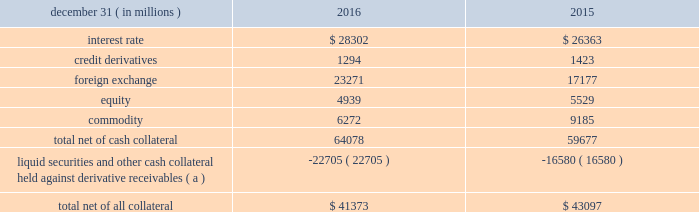Management 2019s discussion and analysis 102 jpmorgan chase & co./2016 annual report derivative contracts in the normal course of business , the firm uses derivative instruments predominantly for market-making activities .
Derivatives enable customers to manage exposures to fluctuations in interest rates , currencies and other markets .
The firm also uses derivative instruments to manage its own credit and other market risk exposure .
The nature of the counterparty and the settlement mechanism of the derivative affect the credit risk to which the firm is exposed .
For otc derivatives the firm is exposed to the credit risk of the derivative counterparty .
For exchange- traded derivatives ( 201cetd 201d ) , such as futures and options and 201ccleared 201d over-the-counter ( 201cotc-cleared 201d ) derivatives , the firm is generally exposed to the credit risk of the relevant ccp .
Where possible , the firm seeks to mitigate its credit risk exposures arising from derivative transactions through the use of legally enforceable master netting arrangements and collateral agreements .
For further discussion of derivative contracts , counterparties and settlement types , see note 6 .
The table summarizes the net derivative receivables for the periods presented .
Derivative receivables .
( a ) includes collateral related to derivative instruments where an appropriate legal opinion has not been either sought or obtained .
Derivative receivables reported on the consolidated balance sheets were $ 64.1 billion and $ 59.7 billion at december 31 , 2016 and 2015 , respectively .
These amounts represent the fair value of the derivative contracts after giving effect to legally enforceable master netting agreements and cash collateral held by the firm .
However , in management 2019s view , the appropriate measure of current credit risk should also take into consideration additional liquid securities ( primarily u.s .
Government and agency securities and other group of seven nations ( 201cg7 201d ) government bonds ) and other cash collateral held by the firm aggregating $ 22.7 billion and $ 16.6 billion at december 31 , 2016 and 2015 , respectively , that may be used as security when the fair value of the client 2019s exposure is in the firm 2019s favor .
The change in derivative receivables was predominantly related to client-driven market-making activities in cib .
The increase in derivative receivables reflected the impact of market movements , which increased foreign exchange receivables , partially offset by reduced commodity derivative receivables .
In addition to the collateral described in the preceding paragraph , the firm also holds additional collateral ( primarily cash , g7 government securities , other liquid government-agency and guaranteed securities , and corporate debt and equity securities ) delivered by clients at the initiation of transactions , as well as collateral related to contracts that have a non-daily call frequency and collateral that the firm has agreed to return but has not yet settled as of the reporting date .
Although this collateral does not reduce the balances and is not included in the table above , it is available as security against potential exposure that could arise should the fair value of the client 2019s derivative transactions move in the firm 2019s favor .
The derivative receivables fair value , net of all collateral , also does not include other credit enhancements , such as letters of credit .
For additional information on the firm 2019s use of collateral agreements , see note 6 .
While useful as a current view of credit exposure , the net fair value of the derivative receivables does not capture the potential future variability of that credit exposure .
To capture the potential future variability of credit exposure , the firm calculates , on a client-by-client basis , three measures of potential derivatives-related credit loss : peak , derivative risk equivalent ( 201cdre 201d ) , and average exposure ( 201cavg 201d ) .
These measures all incorporate netting and collateral benefits , where applicable .
Peak represents a conservative measure of potential exposure to a counterparty calculated in a manner that is broadly equivalent to a 97.5% ( 97.5 % ) confidence level over the life of the transaction .
Peak is the primary measure used by the firm for setting of credit limits for derivative transactions , senior management reporting and derivatives exposure management .
Dre exposure is a measure that expresses the risk of derivative exposure on a basis intended to be equivalent to the risk of loan exposures .
Dre is a less extreme measure of potential credit loss than peak and is used for aggregating derivative credit risk exposures with loans and other credit risk .
Finally , avg is a measure of the expected fair value of the firm 2019s derivative receivables at future time periods , including the benefit of collateral .
Avg exposure over the total life of the derivative contract is used as the primary metric for pricing purposes and is used to calculate credit capital and the cva , as further described below .
The three year avg exposure was $ 31.1 billion and $ 32.4 billion at december 31 , 2016 and 2015 , respectively , compared with derivative receivables , net of all collateral , of $ 41.4 billion and $ 43.1 billion at december 31 , 2016 and 2015 , respectively .
The fair value of the firm 2019s derivative receivables incorporates an adjustment , the cva , to reflect the credit quality of counterparties .
The cva is based on the firm 2019s avg to a counterparty and the counterparty 2019s credit spread in the credit derivatives market .
The primary components of changes in cva are credit spreads , new deal activity or unwinds , and changes in the underlying market environment .
The firm believes that active risk management is essential to controlling the dynamic credit .
Commodity derivatives were how much of the 2016 total derivatives? 
Computations: (6272 / 64078)
Answer: 0.09788. 